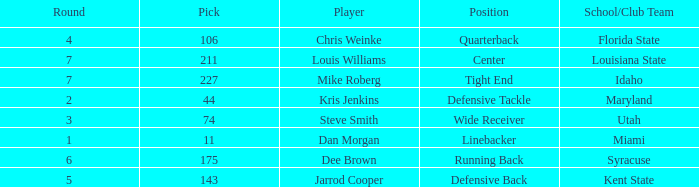Where did steve smith go to school? Utah. 